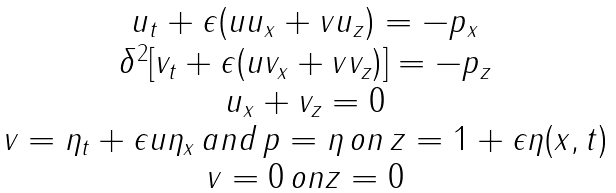<formula> <loc_0><loc_0><loc_500><loc_500>\begin{array} { c } u _ { t } + \epsilon ( u u _ { x } + v u _ { z } ) = - p _ { x } \\ \delta ^ { 2 } [ v _ { t } + \epsilon ( u v _ { x } + v v _ { z } ) ] = - p _ { z } \\ u _ { x } + v _ { z } = 0 \\ v = \eta _ { t } + \epsilon u \eta _ { x } \, a n d \, p = \eta \, o n \, z = 1 + \epsilon \eta ( x , t ) \\ v = 0 \, o n z = 0 \end{array}</formula> 